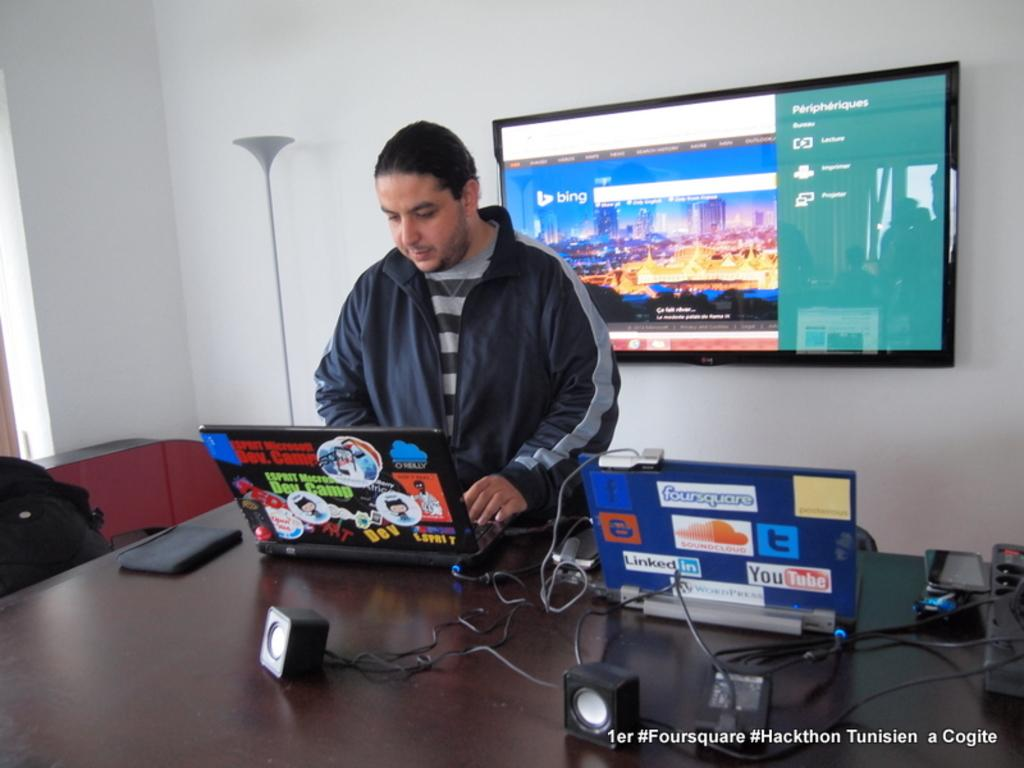<image>
Summarize the visual content of the image. A man is using a lap top with another one next to him open that has stickers on it on the back saying foursquare, SoundCloud, Linkedin, and Youtube. 